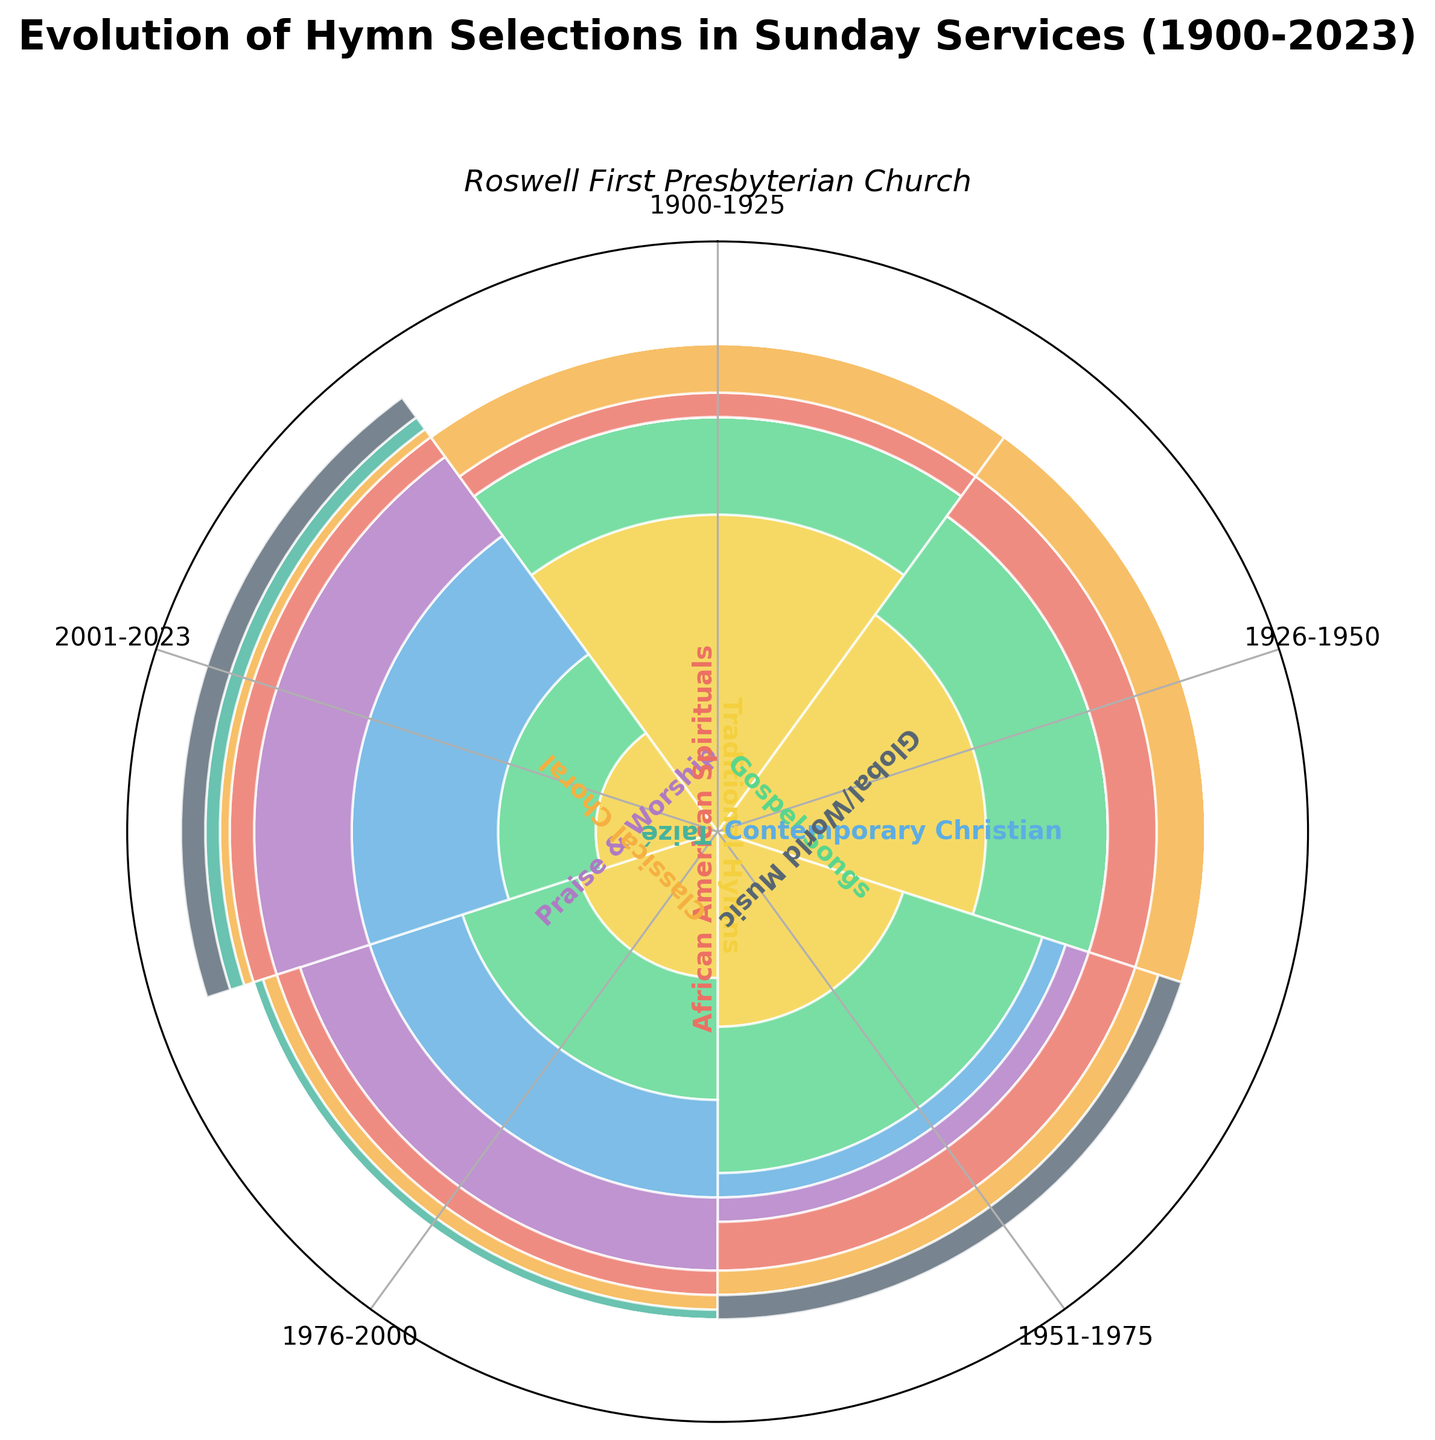What is the title of the figure? The title of the figure is the text presented at the top, usually providing an overview of what the chart is about.
Answer: Evolution of Hymn Selections in Sunday Services (1900-2023) How many categories of hymns are shown in the figure? Count the number of different hymn categories listed in the legend or labels surrounding the chart.
Answer: Eight Which hymn category had the highest selection from 1900-1925? Identify the bar with the greatest extent in the 1900-1925 section of the fan chart.
Answer: Traditional Hymns What is the visible trend for Traditional Hymns from 1900 to 2023? Observe the changes in the length of the bars for Traditional Hymns over different time periods to identify the trend.
Answer: Decreasing Which periods have no representation of Taizé hymns? Look at the sections of the fan chart corresponding to different periods and identify where Taizé hymns are absent.
Answer: 1900-1925, 1926-1950, 1951-1975 How do the selections for Contemporary Christian hymns compare from 1976-2000 to 2001-2023? Compare the length of bars for Contemporary Christian hymns in the two specified time periods.
Answer: Increased From 1900-1925, which hymn categories had the same selection percentage? Identify categories with bars of the same length for the 1900-1925 period in the fan chart.
Answer: Classical Choral and African American Spirituals In which period did Gospel Songs reach their peak selection? Observe the length of the bars for Gospel Songs in each period and identify the one with the highest length.
Answer: 1951-1975 By looking at the trend, can you predict if Praise & Worship hymns will continue to increase in selection? Analyze the upward or downward trend in the Praise & Worship hymns category over the time periods to forecast future trends.
Answer: Yes If you sum the selections for Global/World Music from all periods, what is the total? Add the values for Global/World Music from each time period.
Answer: 10 